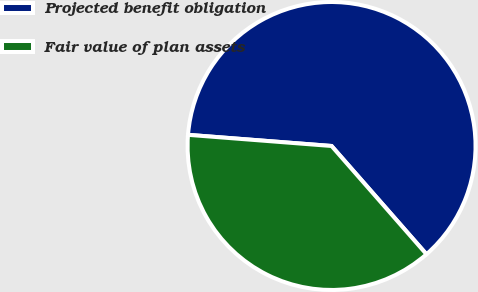Convert chart. <chart><loc_0><loc_0><loc_500><loc_500><pie_chart><fcel>Projected benefit obligation<fcel>Fair value of plan assets<nl><fcel>62.31%<fcel>37.69%<nl></chart> 